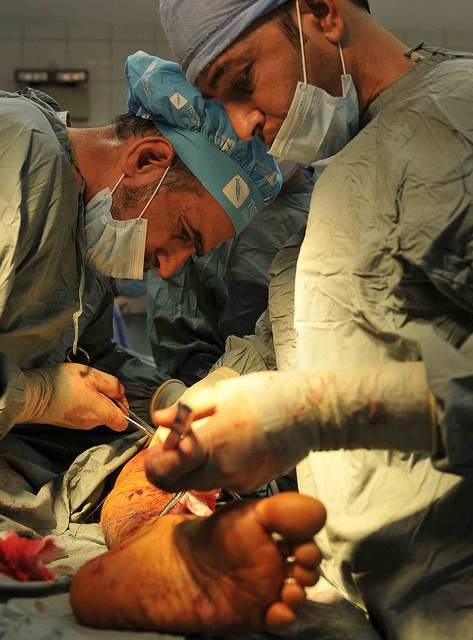Describe the objects in this image and their specific colors. I can see people in gray, black, khaki, and tan tones, people in gray, black, and maroon tones, people in gray, maroon, brown, and black tones, people in gray and black tones, and scissors in gray, black, olive, and maroon tones in this image. 